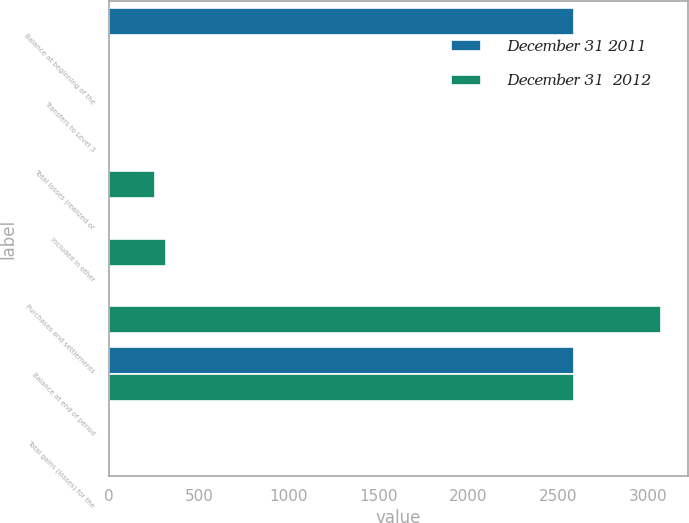Convert chart to OTSL. <chart><loc_0><loc_0><loc_500><loc_500><stacked_bar_chart><ecel><fcel>Balance at beginning of the<fcel>Transfers to Level 3<fcel>Total losses (realized or<fcel>Included in other<fcel>Purchases and settlements<fcel>Balance at end of period<fcel>Total gains (losses) for the<nl><fcel>December 31 2011<fcel>2588<fcel>0<fcel>0<fcel>0<fcel>0<fcel>2588<fcel>0<nl><fcel>December 31  2012<fcel>0<fcel>0<fcel>255<fcel>317<fcel>3071<fcel>2588<fcel>0<nl></chart> 